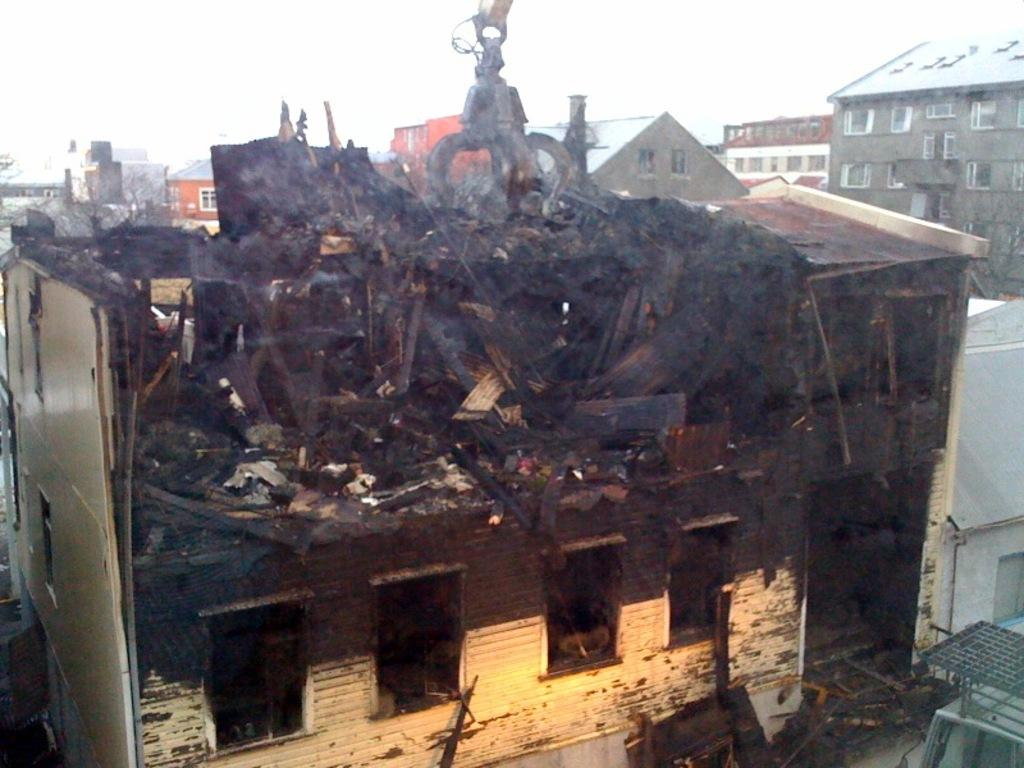What type of structure is featured in the image? There is a renovated building in the image. Can you describe the surrounding area in the image? There are many other buildings visible in the image. What can be seen in the sky in the image? The sky is visible in the image. What statement does the thumb make in the image? There is no thumb present in the image, so it cannot make any statements. 